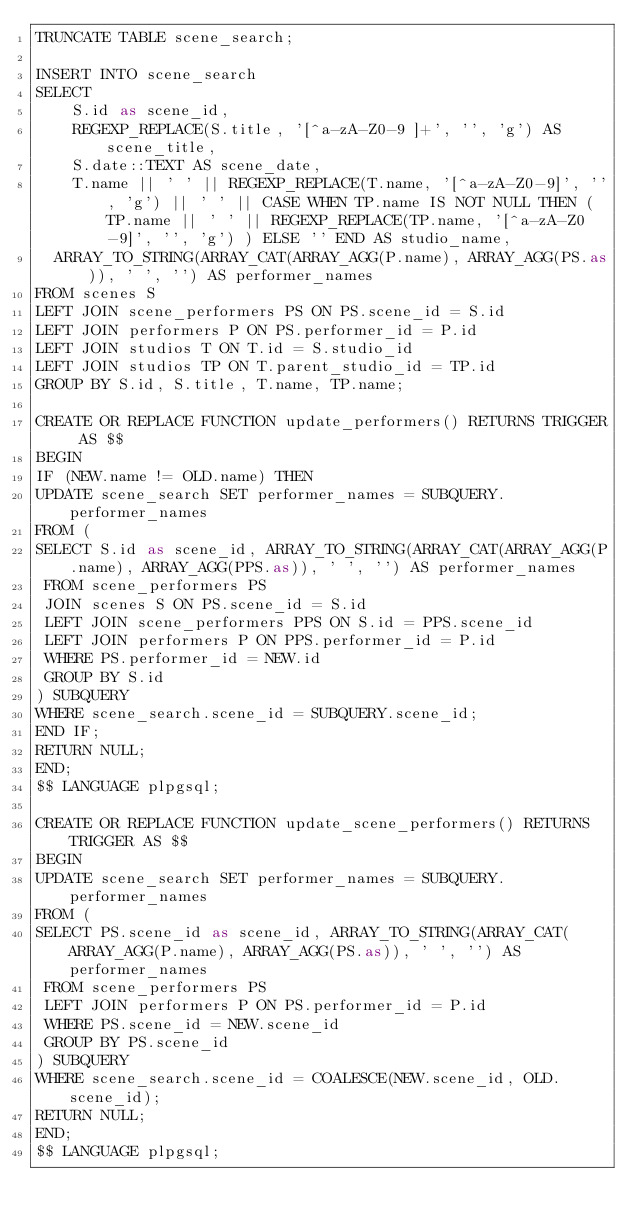<code> <loc_0><loc_0><loc_500><loc_500><_SQL_>TRUNCATE TABLE scene_search;

INSERT INTO scene_search
SELECT
	S.id as scene_id,
	REGEXP_REPLACE(S.title, '[^a-zA-Z0-9 ]+', '', 'g') AS scene_title,
	S.date::TEXT AS scene_date,
	T.name || ' ' || REGEXP_REPLACE(T.name, '[^a-zA-Z0-9]', '', 'g') || ' ' || CASE WHEN TP.name IS NOT NULL THEN (TP.name || ' ' || REGEXP_REPLACE(TP.name, '[^a-zA-Z0-9]', '', 'g') ) ELSE '' END AS studio_name,
  ARRAY_TO_STRING(ARRAY_CAT(ARRAY_AGG(P.name), ARRAY_AGG(PS.as)), ' ', '') AS performer_names
FROM scenes S
LEFT JOIN scene_performers PS ON PS.scene_id = S.id
LEFT JOIN performers P ON PS.performer_id = P.id
LEFT JOIN studios T ON T.id = S.studio_id
LEFT JOIN studios TP ON T.parent_studio_id = TP.id
GROUP BY S.id, S.title, T.name, TP.name;

CREATE OR REPLACE FUNCTION update_performers() RETURNS TRIGGER AS $$
BEGIN
IF (NEW.name != OLD.name) THEN
UPDATE scene_search SET performer_names = SUBQUERY.performer_names
FROM (
SELECT S.id as scene_id, ARRAY_TO_STRING(ARRAY_CAT(ARRAY_AGG(P.name), ARRAY_AGG(PPS.as)), ' ', '') AS performer_names
 FROM scene_performers PS
 JOIN scenes S ON PS.scene_id = S.id
 LEFT JOIN scene_performers PPS ON S.id = PPS.scene_id
 LEFT JOIN performers P ON PPS.performer_id = P.id
 WHERE PS.performer_id = NEW.id
 GROUP BY S.id
) SUBQUERY
WHERE scene_search.scene_id = SUBQUERY.scene_id;
END IF;
RETURN NULL;
END;
$$ LANGUAGE plpgsql;

CREATE OR REPLACE FUNCTION update_scene_performers() RETURNS TRIGGER AS $$
BEGIN
UPDATE scene_search SET performer_names = SUBQUERY.performer_names
FROM (
SELECT PS.scene_id as scene_id, ARRAY_TO_STRING(ARRAY_CAT(ARRAY_AGG(P.name), ARRAY_AGG(PS.as)), ' ', '') AS performer_names
 FROM scene_performers PS
 LEFT JOIN performers P ON PS.performer_id = P.id
 WHERE PS.scene_id = NEW.scene_id
 GROUP BY PS.scene_id
) SUBQUERY
WHERE scene_search.scene_id = COALESCE(NEW.scene_id, OLD.scene_id);
RETURN NULL;
END;
$$ LANGUAGE plpgsql;
</code> 